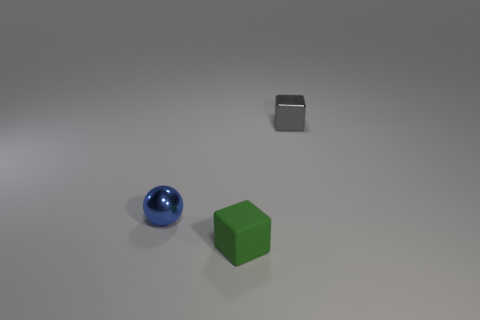What is the color of the metallic thing behind the tiny metal object that is left of the tiny gray thing?
Your response must be concise. Gray. Does the blue ball have the same size as the gray thing?
Keep it short and to the point. Yes. There is another gray thing that is the same shape as the tiny matte object; what is it made of?
Your answer should be compact. Metal. What number of green rubber things have the same size as the gray thing?
Make the answer very short. 1. What color is the tiny object that is made of the same material as the sphere?
Your response must be concise. Gray. Are there fewer metal balls than green rubber cylinders?
Keep it short and to the point. No. What number of yellow objects are either tiny rubber objects or small metal things?
Keep it short and to the point. 0. How many objects are both in front of the blue sphere and right of the matte object?
Your answer should be compact. 0. Is the blue thing made of the same material as the green thing?
Keep it short and to the point. No. What is the shape of the gray metallic object that is the same size as the green object?
Ensure brevity in your answer.  Cube. 